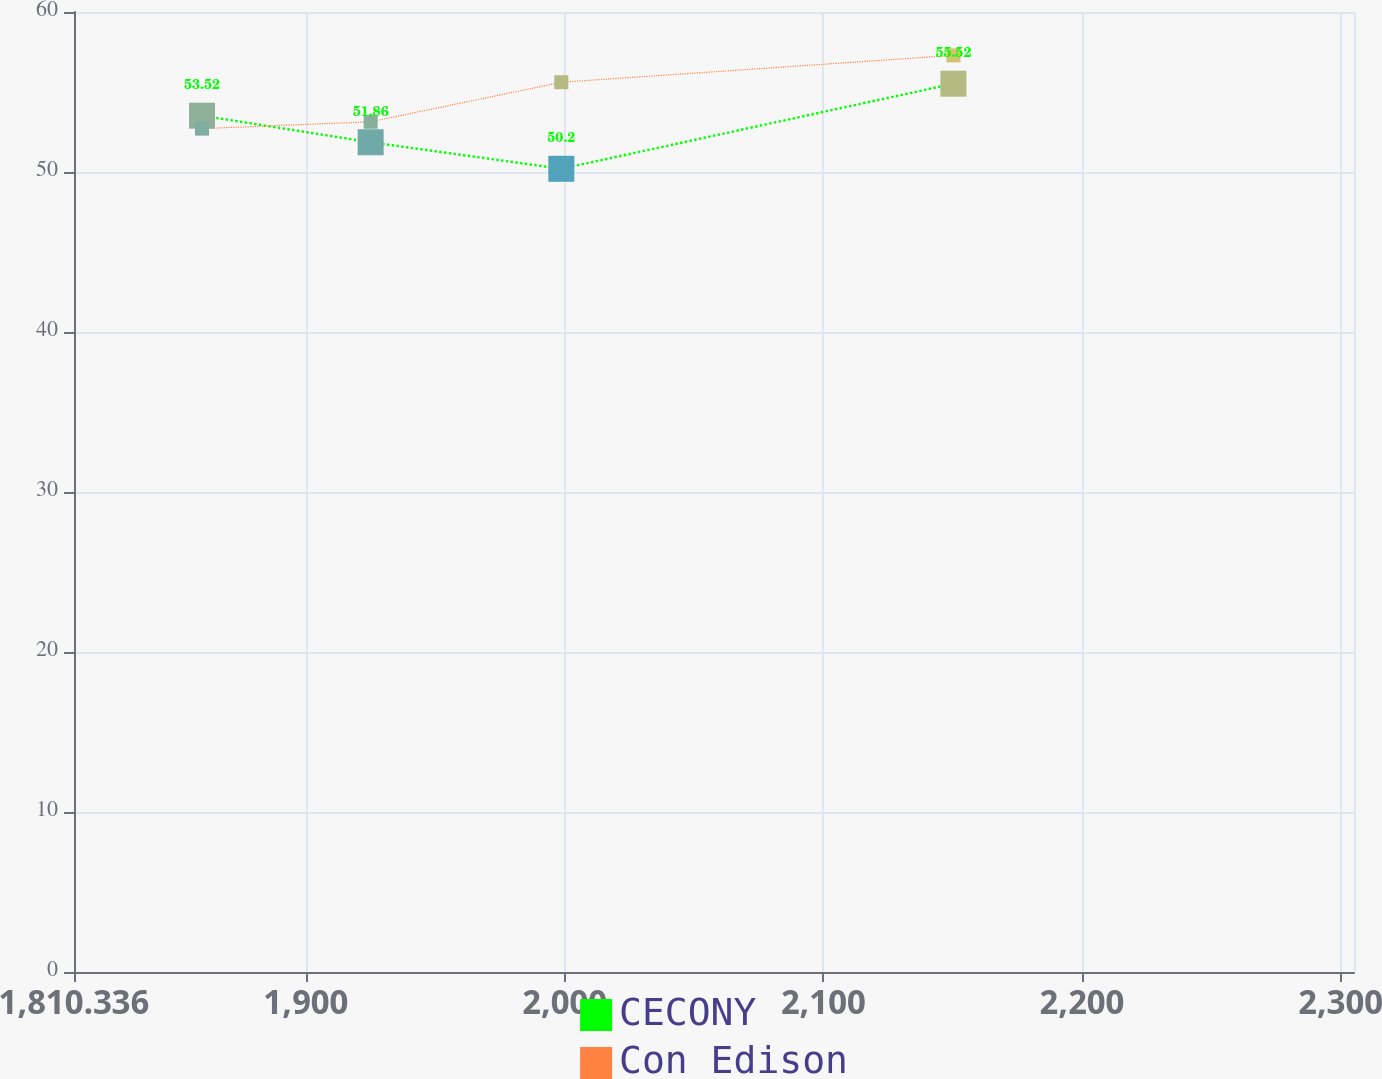<chart> <loc_0><loc_0><loc_500><loc_500><line_chart><ecel><fcel>CECONY<fcel>Con Edison<nl><fcel>1859.82<fcel>53.52<fcel>52.71<nl><fcel>1925.02<fcel>51.86<fcel>53.14<nl><fcel>1998.73<fcel>50.2<fcel>55.61<nl><fcel>2150.31<fcel>55.52<fcel>57.29<nl><fcel>2354.66<fcel>66.82<fcel>56.86<nl></chart> 